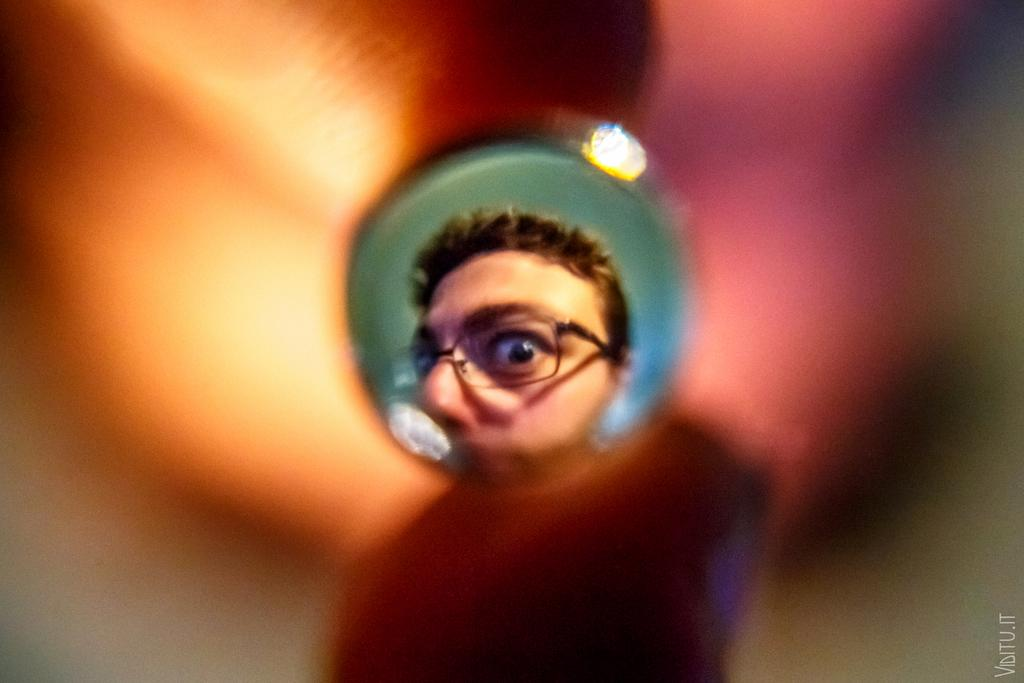Who or what is present in the image? There is a person in the image. What can be observed about the person's appearance? The person is wearing spectacles. Are there any additional features or elements in the image? Yes, there is a watermark in the image. Is there any part of the image that is not clear? Yes, a part of the image is blurred. What type of soup is being served in the image? There is no soup present in the image. How many cakes can be seen on the person's foot in the image? There is no foot or cake present in the image. 